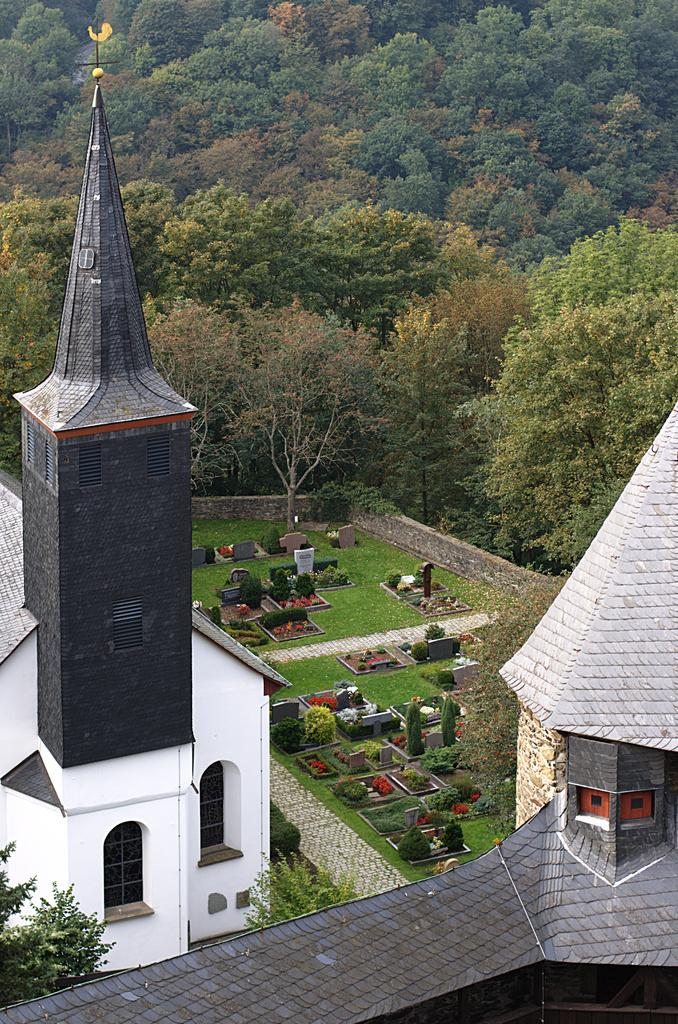What structures are present in the image? There are towers in the image. What type of vegetation can be seen in the background of the image? There are trees in the background of the image. What type of vegetation is at the bottom of the image? There are bushes and grass at the bottom of the image. What type of toy can be seen in the image? There is no toy present in the image. What type of fruit is growing on the trees in the image? There is no fruit visible on the trees in the image. 